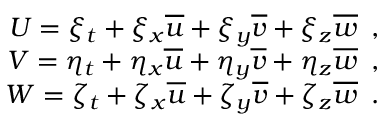Convert formula to latex. <formula><loc_0><loc_0><loc_500><loc_500>\begin{array} { r } { U = \xi _ { t } + \xi _ { x } \overline { u } + \xi _ { y } \overline { v } + \xi _ { z } \overline { w } \, , } \\ { V = \eta _ { t } + \eta _ { x } \overline { u } + \eta _ { y } \overline { v } + \eta _ { z } \overline { w } \, , } \\ { W = \zeta _ { t } + \zeta _ { x } \overline { u } + \zeta _ { y } \overline { v } + \zeta _ { z } \overline { w } \, . } \end{array}</formula> 